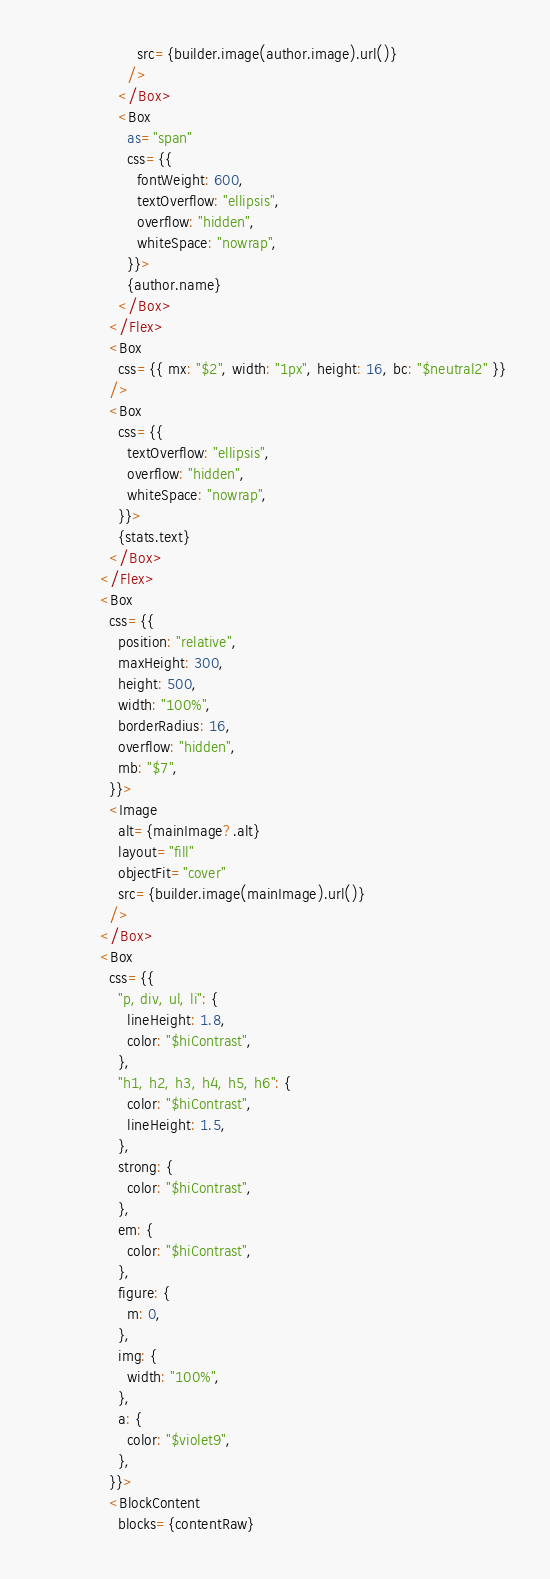<code> <loc_0><loc_0><loc_500><loc_500><_TypeScript_>                    src={builder.image(author.image).url()}
                  />
                </Box>
                <Box
                  as="span"
                  css={{
                    fontWeight: 600,
                    textOverflow: "ellipsis",
                    overflow: "hidden",
                    whiteSpace: "nowrap",
                  }}>
                  {author.name}
                </Box>
              </Flex>
              <Box
                css={{ mx: "$2", width: "1px", height: 16, bc: "$neutral2" }}
              />
              <Box
                css={{
                  textOverflow: "ellipsis",
                  overflow: "hidden",
                  whiteSpace: "nowrap",
                }}>
                {stats.text}
              </Box>
            </Flex>
            <Box
              css={{
                position: "relative",
                maxHeight: 300,
                height: 500,
                width: "100%",
                borderRadius: 16,
                overflow: "hidden",
                mb: "$7",
              }}>
              <Image
                alt={mainImage?.alt}
                layout="fill"
                objectFit="cover"
                src={builder.image(mainImage).url()}
              />
            </Box>
            <Box
              css={{
                "p, div, ul, li": {
                  lineHeight: 1.8,
                  color: "$hiContrast",
                },
                "h1, h2, h3, h4, h5, h6": {
                  color: "$hiContrast",
                  lineHeight: 1.5,
                },
                strong: {
                  color: "$hiContrast",
                },
                em: {
                  color: "$hiContrast",
                },
                figure: {
                  m: 0,
                },
                img: {
                  width: "100%",
                },
                a: {
                  color: "$violet9",
                },
              }}>
              <BlockContent
                blocks={contentRaw}</code> 